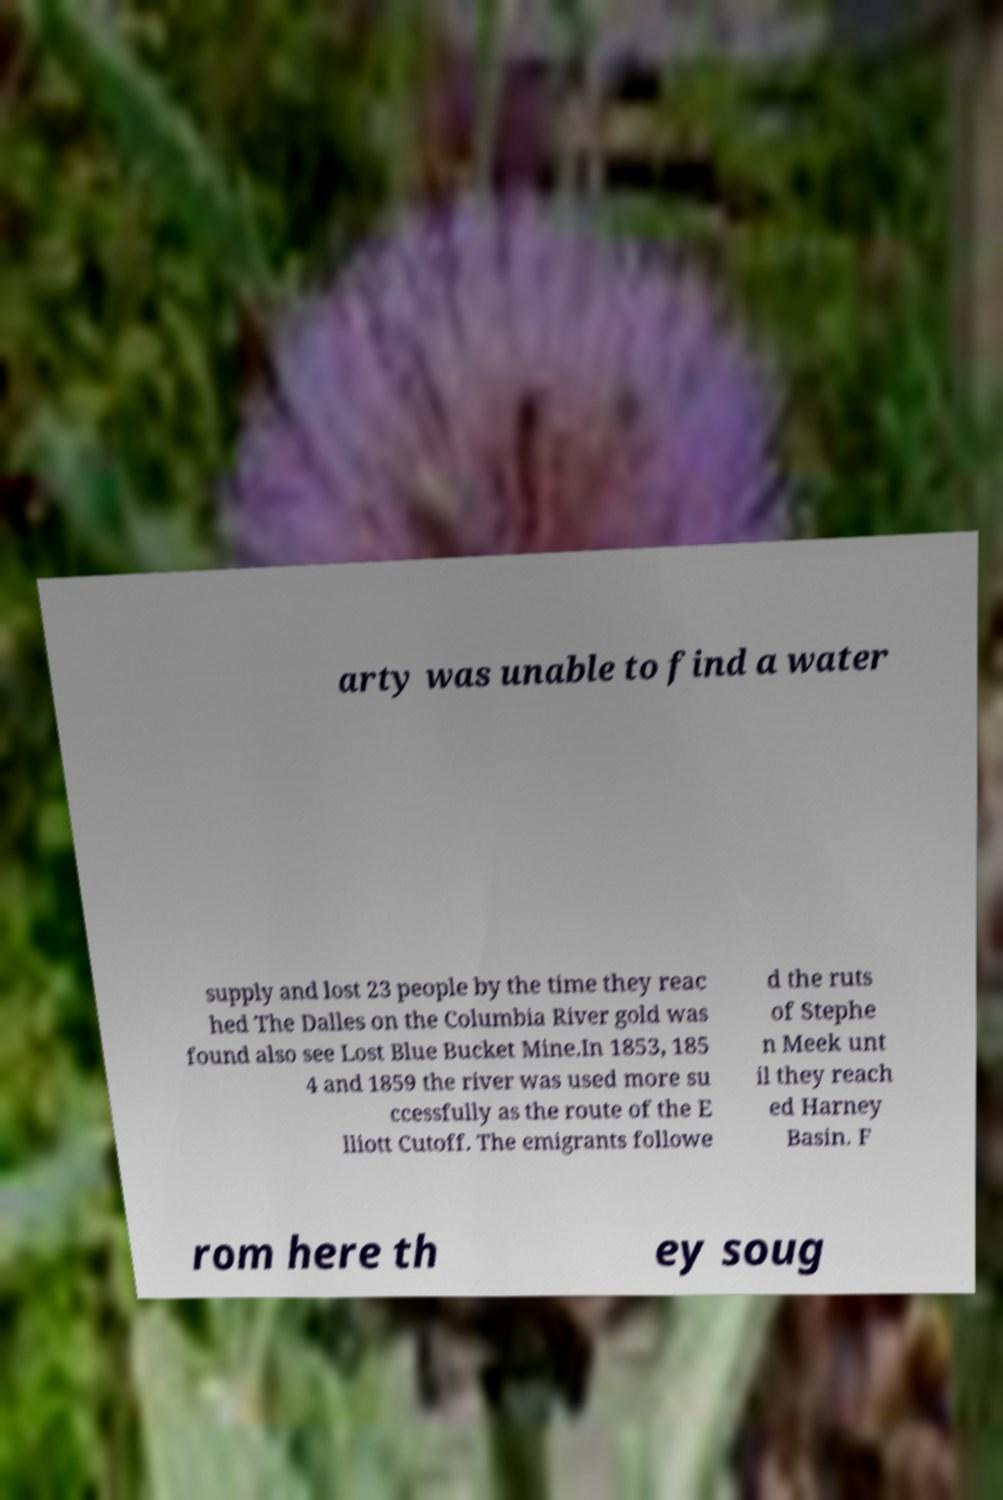Could you assist in decoding the text presented in this image and type it out clearly? arty was unable to find a water supply and lost 23 people by the time they reac hed The Dalles on the Columbia River gold was found also see Lost Blue Bucket Mine.In 1853, 185 4 and 1859 the river was used more su ccessfully as the route of the E lliott Cutoff. The emigrants followe d the ruts of Stephe n Meek unt il they reach ed Harney Basin. F rom here th ey soug 